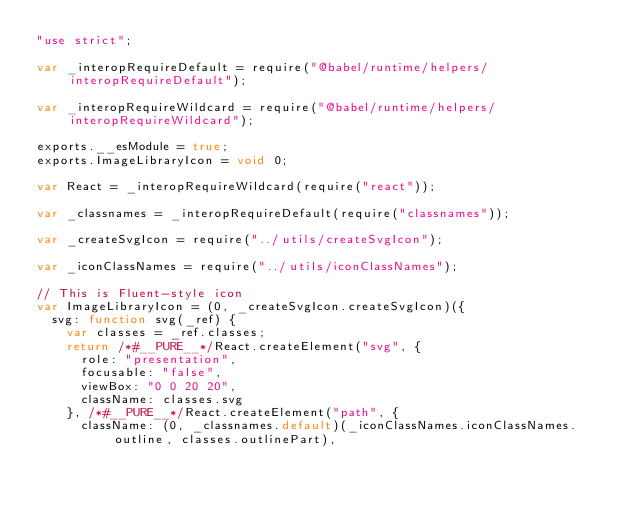<code> <loc_0><loc_0><loc_500><loc_500><_JavaScript_>"use strict";

var _interopRequireDefault = require("@babel/runtime/helpers/interopRequireDefault");

var _interopRequireWildcard = require("@babel/runtime/helpers/interopRequireWildcard");

exports.__esModule = true;
exports.ImageLibraryIcon = void 0;

var React = _interopRequireWildcard(require("react"));

var _classnames = _interopRequireDefault(require("classnames"));

var _createSvgIcon = require("../utils/createSvgIcon");

var _iconClassNames = require("../utils/iconClassNames");

// This is Fluent-style icon
var ImageLibraryIcon = (0, _createSvgIcon.createSvgIcon)({
  svg: function svg(_ref) {
    var classes = _ref.classes;
    return /*#__PURE__*/React.createElement("svg", {
      role: "presentation",
      focusable: "false",
      viewBox: "0 0 20 20",
      className: classes.svg
    }, /*#__PURE__*/React.createElement("path", {
      className: (0, _classnames.default)(_iconClassNames.iconClassNames.outline, classes.outlinePart),</code> 